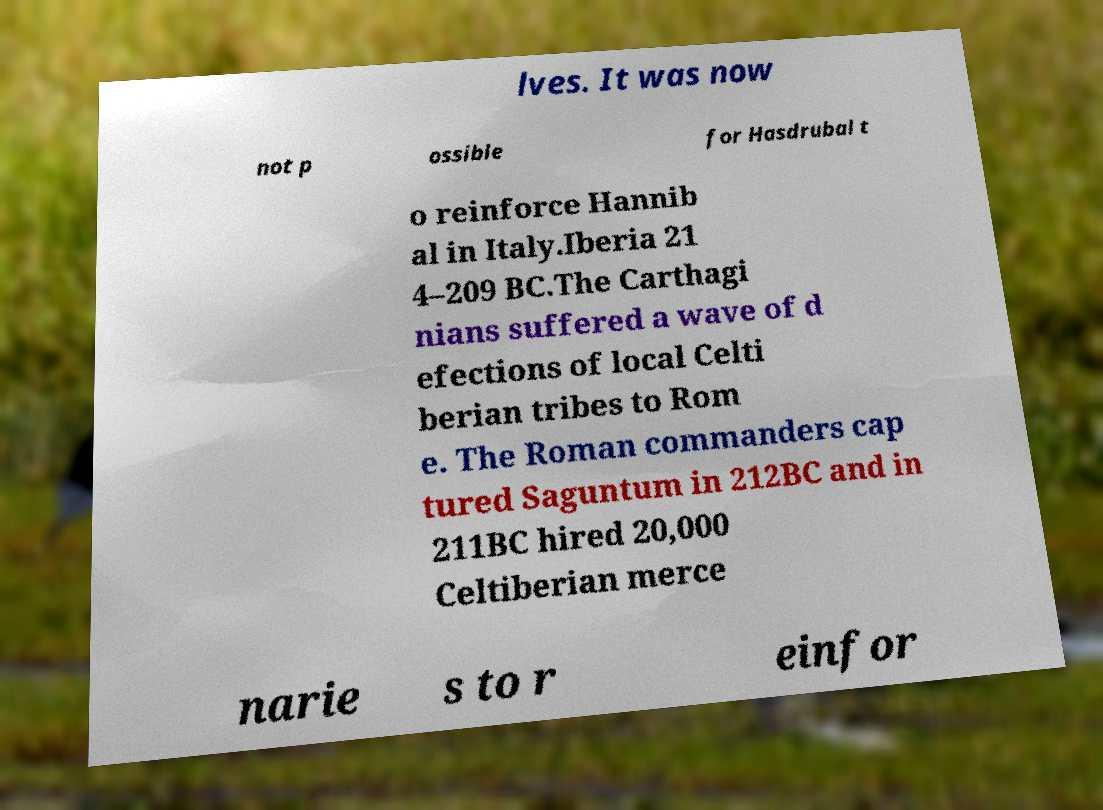What messages or text are displayed in this image? I need them in a readable, typed format. lves. It was now not p ossible for Hasdrubal t o reinforce Hannib al in Italy.Iberia 21 4–209 BC.The Carthagi nians suffered a wave of d efections of local Celti berian tribes to Rom e. The Roman commanders cap tured Saguntum in 212BC and in 211BC hired 20,000 Celtiberian merce narie s to r einfor 